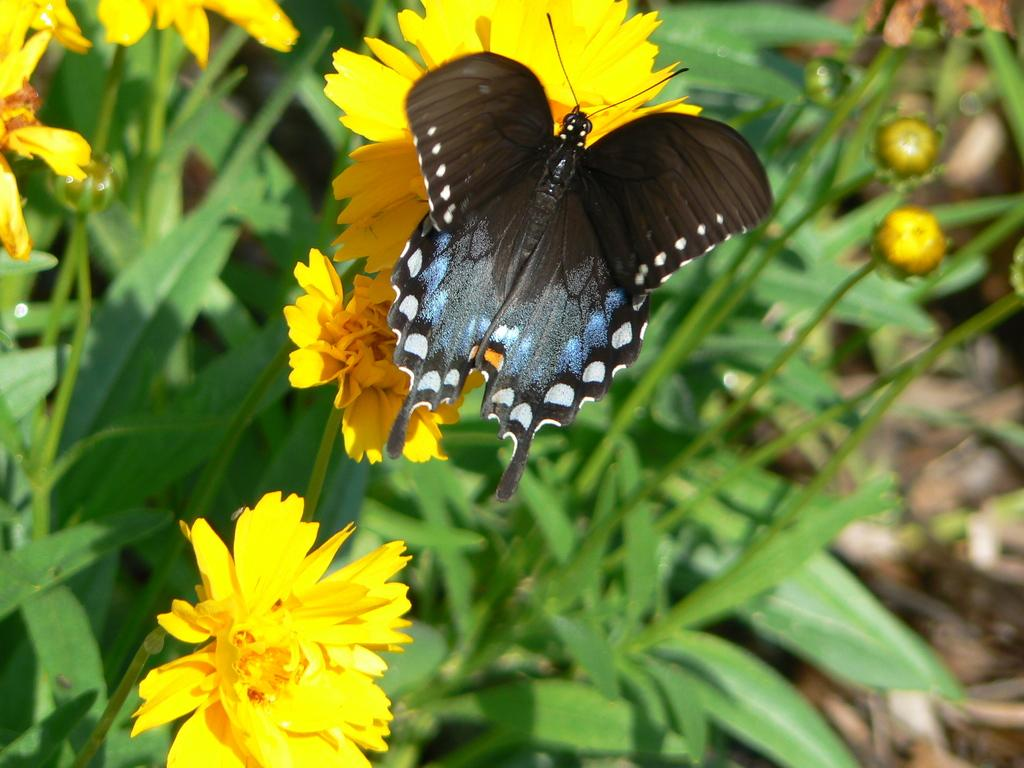What type of creature is in the image? There is a butterfly in the image. What colors can be seen on the butterfly? The butterfly has black, white, and blue colors. Where is the butterfly located in the image? The butterfly is on a flower. What color are the flowers that the butterfly is on? The flowers are yellow. What color are the plants that have the yellow flowers? The plants are green in color. Can you see a deer with a sore throat in the image? There is no deer or mention of a sore throat in the image; it features a butterfly on a yellow flower. 